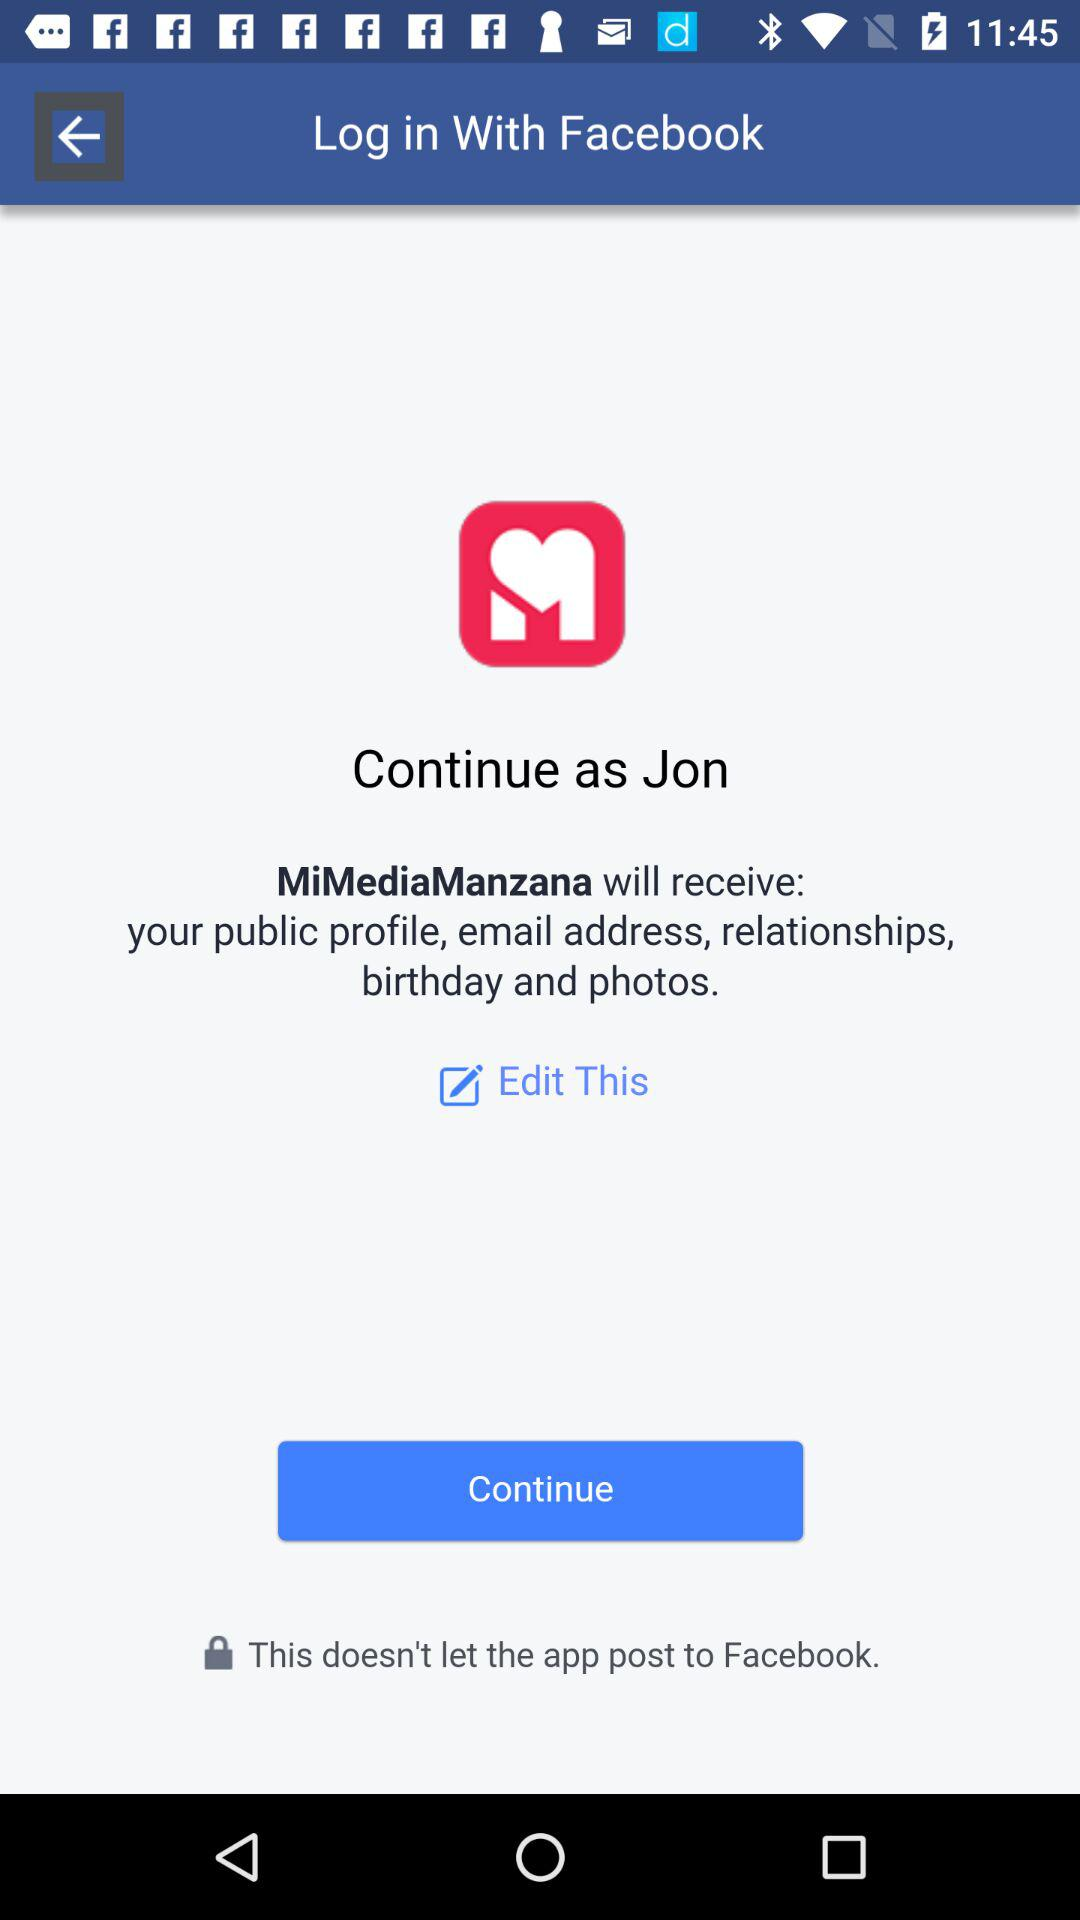Which information will "MiMediaManzana" receive? "MiMediaManzana" will receive your public profile, email address, relationships, birthday and photos. 